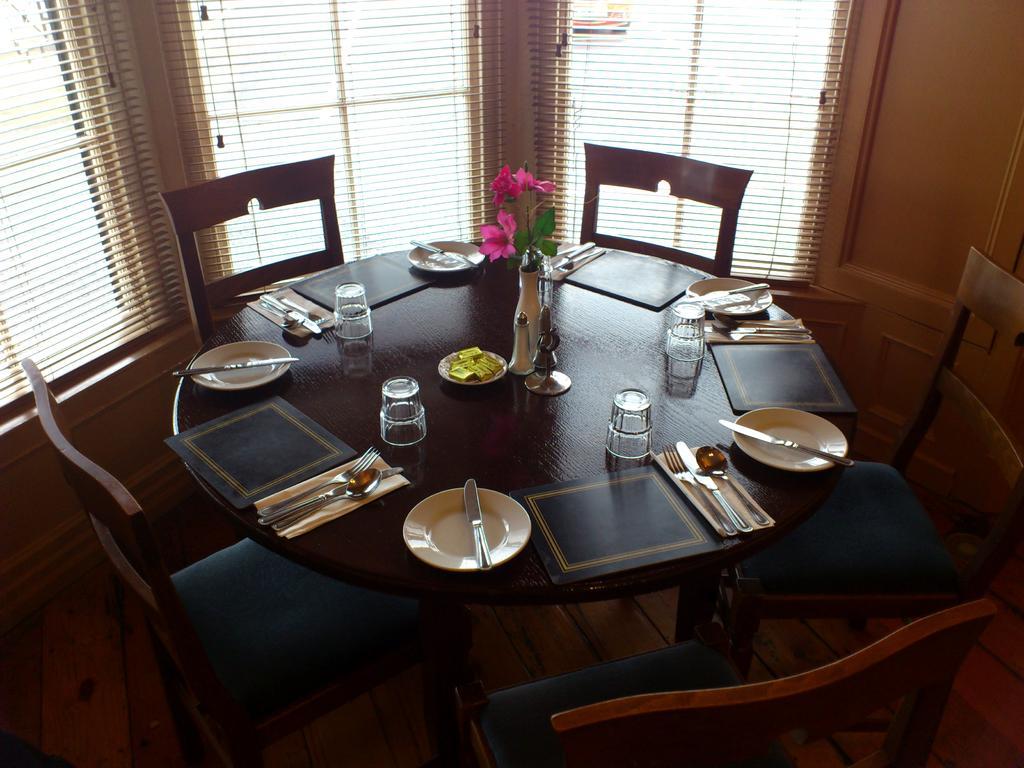Could you give a brief overview of what you see in this image? In the center of the image there is a table and on top of the table there are plates, knives forks, spoons, glasses, flower pot and a few other objects. Around the table there are chairs. At the bottom of the image there is a wooden floor. In the background of the image there are windows. 